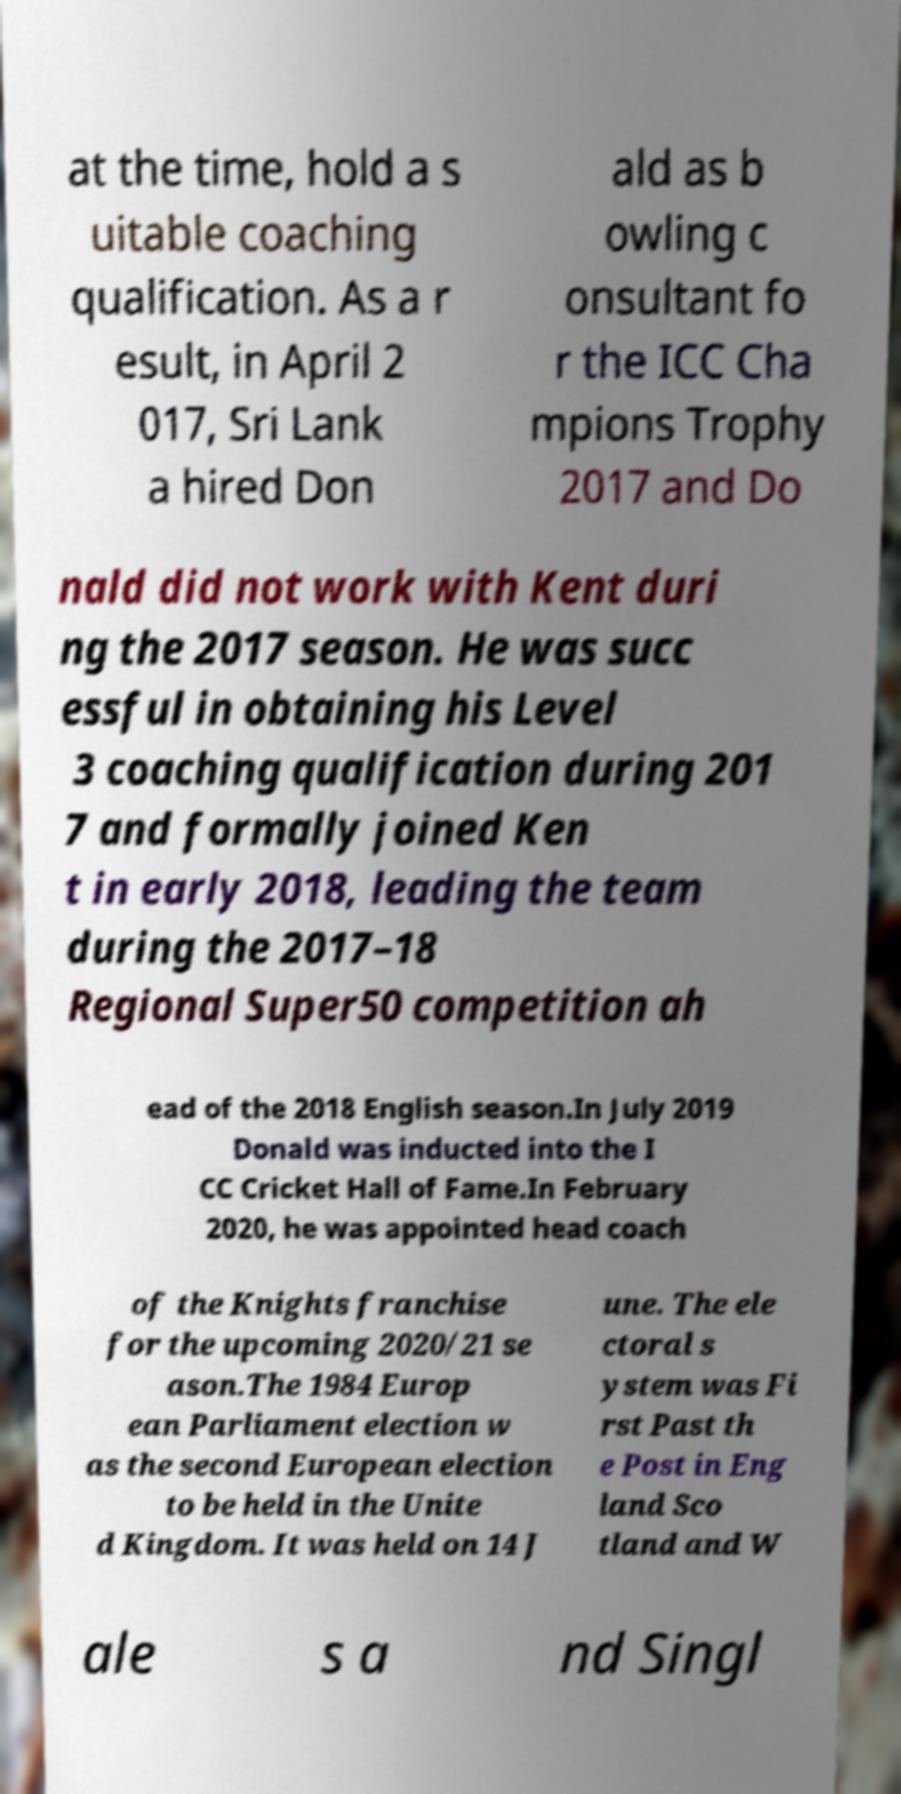Please read and relay the text visible in this image. What does it say? at the time, hold a s uitable coaching qualification. As a r esult, in April 2 017, Sri Lank a hired Don ald as b owling c onsultant fo r the ICC Cha mpions Trophy 2017 and Do nald did not work with Kent duri ng the 2017 season. He was succ essful in obtaining his Level 3 coaching qualification during 201 7 and formally joined Ken t in early 2018, leading the team during the 2017–18 Regional Super50 competition ah ead of the 2018 English season.In July 2019 Donald was inducted into the I CC Cricket Hall of Fame.In February 2020, he was appointed head coach of the Knights franchise for the upcoming 2020/21 se ason.The 1984 Europ ean Parliament election w as the second European election to be held in the Unite d Kingdom. It was held on 14 J une. The ele ctoral s ystem was Fi rst Past th e Post in Eng land Sco tland and W ale s a nd Singl 